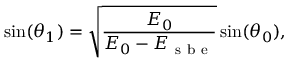Convert formula to latex. <formula><loc_0><loc_0><loc_500><loc_500>\sin ( \theta _ { 1 } ) = \sqrt { \frac { E _ { 0 } } { E _ { 0 } - E _ { s b e } } } \sin ( \theta _ { 0 } ) ,</formula> 